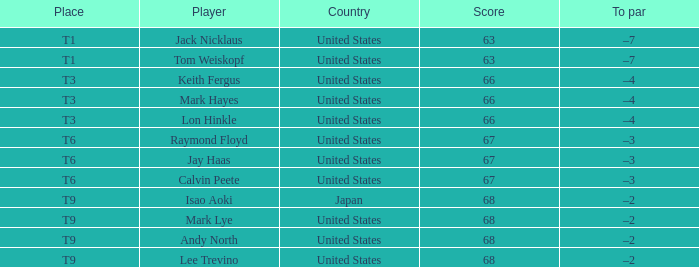When the place is "t9" and the player is "lee trevino", what does to par refer to? –2. 